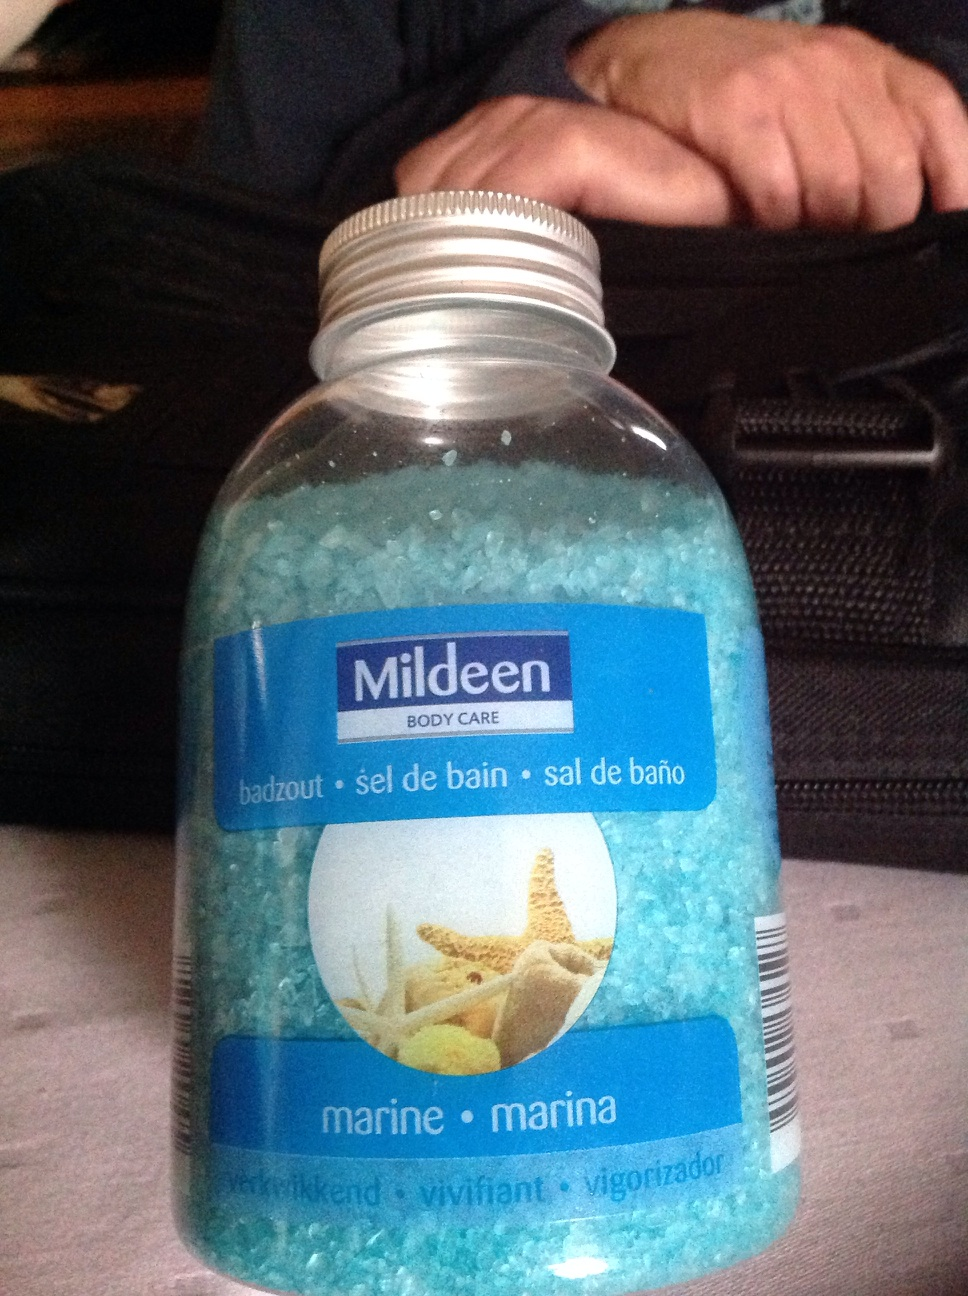What's this? This is a container of Mildeen Body Care bath salts. The product is labeled as 'marine' and features rejuvenating properties, ideal for a relaxing bath experience. The teal color of the salt suggests a refreshing ocean-themed aroma. 